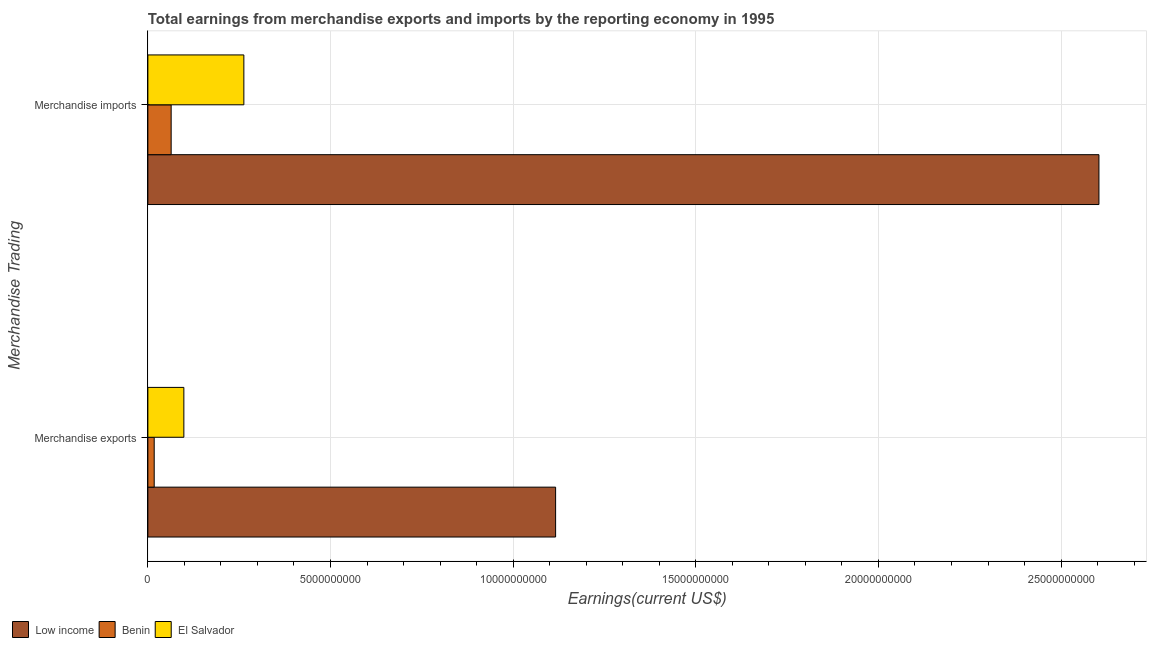How many bars are there on the 1st tick from the top?
Make the answer very short. 3. How many bars are there on the 2nd tick from the bottom?
Provide a succinct answer. 3. What is the earnings from merchandise exports in Benin?
Keep it short and to the point. 1.73e+08. Across all countries, what is the maximum earnings from merchandise exports?
Make the answer very short. 1.12e+1. Across all countries, what is the minimum earnings from merchandise imports?
Make the answer very short. 6.37e+08. In which country was the earnings from merchandise imports minimum?
Offer a very short reply. Benin. What is the total earnings from merchandise imports in the graph?
Give a very brief answer. 2.93e+1. What is the difference between the earnings from merchandise exports in Low income and that in Benin?
Provide a short and direct response. 1.10e+1. What is the difference between the earnings from merchandise imports in El Salvador and the earnings from merchandise exports in Benin?
Your answer should be very brief. 2.45e+09. What is the average earnings from merchandise exports per country?
Keep it short and to the point. 4.11e+09. What is the difference between the earnings from merchandise exports and earnings from merchandise imports in Low income?
Make the answer very short. -1.49e+1. In how many countries, is the earnings from merchandise imports greater than 20000000000 US$?
Your response must be concise. 1. What is the ratio of the earnings from merchandise imports in El Salvador to that in Benin?
Provide a succinct answer. 4.12. Is the earnings from merchandise exports in Benin less than that in El Salvador?
Keep it short and to the point. Yes. In how many countries, is the earnings from merchandise imports greater than the average earnings from merchandise imports taken over all countries?
Give a very brief answer. 1. What does the 1st bar from the top in Merchandise exports represents?
Ensure brevity in your answer.  El Salvador. What does the 2nd bar from the bottom in Merchandise imports represents?
Make the answer very short. Benin. How many bars are there?
Your answer should be compact. 6. What is the difference between two consecutive major ticks on the X-axis?
Offer a very short reply. 5.00e+09. Are the values on the major ticks of X-axis written in scientific E-notation?
Provide a short and direct response. No. Where does the legend appear in the graph?
Ensure brevity in your answer.  Bottom left. How are the legend labels stacked?
Your response must be concise. Horizontal. What is the title of the graph?
Your answer should be compact. Total earnings from merchandise exports and imports by the reporting economy in 1995. Does "South Africa" appear as one of the legend labels in the graph?
Ensure brevity in your answer.  No. What is the label or title of the X-axis?
Offer a very short reply. Earnings(current US$). What is the label or title of the Y-axis?
Give a very brief answer. Merchandise Trading. What is the Earnings(current US$) in Low income in Merchandise exports?
Offer a very short reply. 1.12e+1. What is the Earnings(current US$) in Benin in Merchandise exports?
Keep it short and to the point. 1.73e+08. What is the Earnings(current US$) of El Salvador in Merchandise exports?
Ensure brevity in your answer.  9.85e+08. What is the Earnings(current US$) in Low income in Merchandise imports?
Offer a terse response. 2.60e+1. What is the Earnings(current US$) of Benin in Merchandise imports?
Your answer should be very brief. 6.37e+08. What is the Earnings(current US$) in El Salvador in Merchandise imports?
Give a very brief answer. 2.63e+09. Across all Merchandise Trading, what is the maximum Earnings(current US$) of Low income?
Offer a very short reply. 2.60e+1. Across all Merchandise Trading, what is the maximum Earnings(current US$) of Benin?
Your answer should be compact. 6.37e+08. Across all Merchandise Trading, what is the maximum Earnings(current US$) in El Salvador?
Keep it short and to the point. 2.63e+09. Across all Merchandise Trading, what is the minimum Earnings(current US$) in Low income?
Provide a short and direct response. 1.12e+1. Across all Merchandise Trading, what is the minimum Earnings(current US$) of Benin?
Offer a very short reply. 1.73e+08. Across all Merchandise Trading, what is the minimum Earnings(current US$) of El Salvador?
Offer a terse response. 9.85e+08. What is the total Earnings(current US$) in Low income in the graph?
Provide a short and direct response. 3.72e+1. What is the total Earnings(current US$) of Benin in the graph?
Your answer should be compact. 8.11e+08. What is the total Earnings(current US$) of El Salvador in the graph?
Keep it short and to the point. 3.61e+09. What is the difference between the Earnings(current US$) of Low income in Merchandise exports and that in Merchandise imports?
Provide a succinct answer. -1.49e+1. What is the difference between the Earnings(current US$) of Benin in Merchandise exports and that in Merchandise imports?
Offer a terse response. -4.64e+08. What is the difference between the Earnings(current US$) in El Salvador in Merchandise exports and that in Merchandise imports?
Make the answer very short. -1.64e+09. What is the difference between the Earnings(current US$) of Low income in Merchandise exports and the Earnings(current US$) of Benin in Merchandise imports?
Keep it short and to the point. 1.05e+1. What is the difference between the Earnings(current US$) of Low income in Merchandise exports and the Earnings(current US$) of El Salvador in Merchandise imports?
Provide a succinct answer. 8.53e+09. What is the difference between the Earnings(current US$) of Benin in Merchandise exports and the Earnings(current US$) of El Salvador in Merchandise imports?
Your answer should be very brief. -2.45e+09. What is the average Earnings(current US$) of Low income per Merchandise Trading?
Your answer should be very brief. 1.86e+1. What is the average Earnings(current US$) of Benin per Merchandise Trading?
Offer a terse response. 4.05e+08. What is the average Earnings(current US$) in El Salvador per Merchandise Trading?
Provide a short and direct response. 1.81e+09. What is the difference between the Earnings(current US$) in Low income and Earnings(current US$) in Benin in Merchandise exports?
Keep it short and to the point. 1.10e+1. What is the difference between the Earnings(current US$) of Low income and Earnings(current US$) of El Salvador in Merchandise exports?
Ensure brevity in your answer.  1.02e+1. What is the difference between the Earnings(current US$) in Benin and Earnings(current US$) in El Salvador in Merchandise exports?
Your response must be concise. -8.12e+08. What is the difference between the Earnings(current US$) in Low income and Earnings(current US$) in Benin in Merchandise imports?
Make the answer very short. 2.54e+1. What is the difference between the Earnings(current US$) of Low income and Earnings(current US$) of El Salvador in Merchandise imports?
Ensure brevity in your answer.  2.34e+1. What is the difference between the Earnings(current US$) in Benin and Earnings(current US$) in El Salvador in Merchandise imports?
Your response must be concise. -1.99e+09. What is the ratio of the Earnings(current US$) in Low income in Merchandise exports to that in Merchandise imports?
Offer a very short reply. 0.43. What is the ratio of the Earnings(current US$) in Benin in Merchandise exports to that in Merchandise imports?
Your answer should be very brief. 0.27. What is the ratio of the Earnings(current US$) of El Salvador in Merchandise exports to that in Merchandise imports?
Ensure brevity in your answer.  0.37. What is the difference between the highest and the second highest Earnings(current US$) in Low income?
Provide a short and direct response. 1.49e+1. What is the difference between the highest and the second highest Earnings(current US$) of Benin?
Your response must be concise. 4.64e+08. What is the difference between the highest and the second highest Earnings(current US$) of El Salvador?
Offer a very short reply. 1.64e+09. What is the difference between the highest and the lowest Earnings(current US$) of Low income?
Provide a succinct answer. 1.49e+1. What is the difference between the highest and the lowest Earnings(current US$) in Benin?
Provide a succinct answer. 4.64e+08. What is the difference between the highest and the lowest Earnings(current US$) of El Salvador?
Offer a terse response. 1.64e+09. 